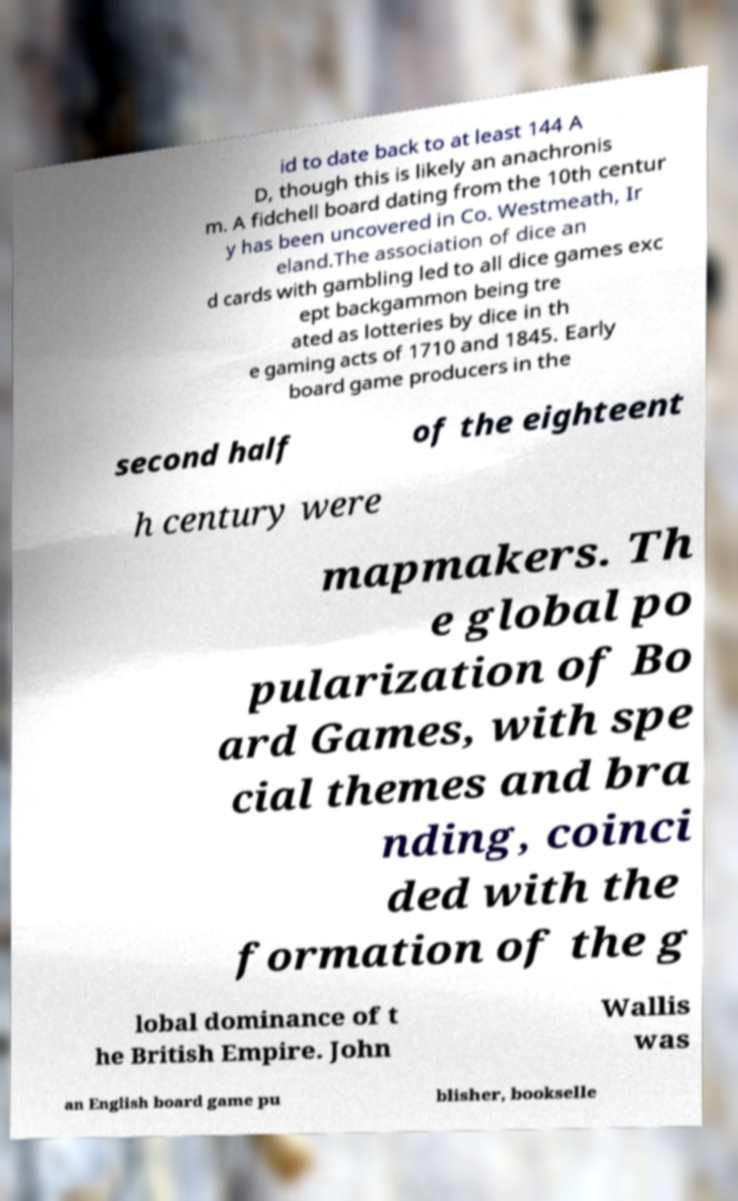Could you assist in decoding the text presented in this image and type it out clearly? id to date back to at least 144 A D, though this is likely an anachronis m. A fidchell board dating from the 10th centur y has been uncovered in Co. Westmeath, Ir eland.The association of dice an d cards with gambling led to all dice games exc ept backgammon being tre ated as lotteries by dice in th e gaming acts of 1710 and 1845. Early board game producers in the second half of the eighteent h century were mapmakers. Th e global po pularization of Bo ard Games, with spe cial themes and bra nding, coinci ded with the formation of the g lobal dominance of t he British Empire. John Wallis was an English board game pu blisher, bookselle 